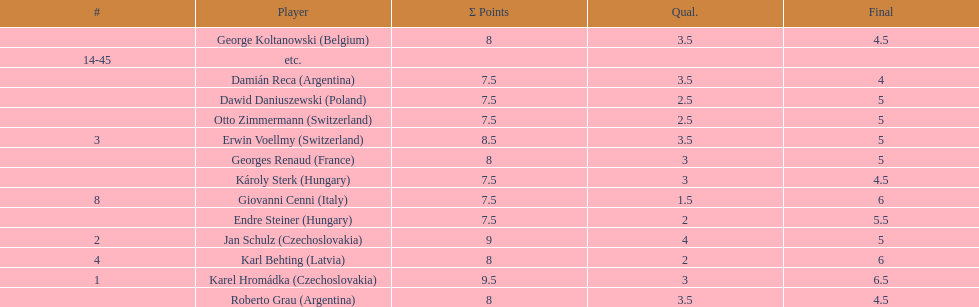Who was the top scorer from switzerland? Erwin Voellmy. 